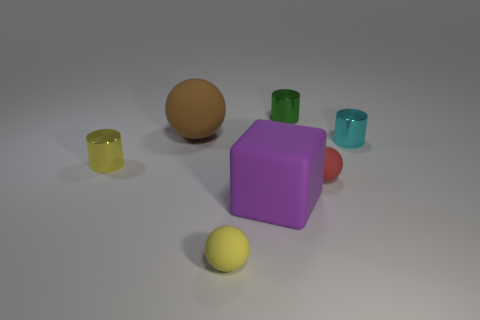Subtract all large matte spheres. How many spheres are left? 2 Add 3 purple objects. How many objects exist? 10 Subtract all yellow spheres. How many spheres are left? 2 Subtract 2 cylinders. How many cylinders are left? 1 Subtract 1 purple blocks. How many objects are left? 6 Subtract all balls. How many objects are left? 4 Subtract all cyan cubes. Subtract all red cylinders. How many cubes are left? 1 Subtract all big brown matte cylinders. Subtract all tiny metal things. How many objects are left? 4 Add 5 red spheres. How many red spheres are left? 6 Add 3 yellow cylinders. How many yellow cylinders exist? 4 